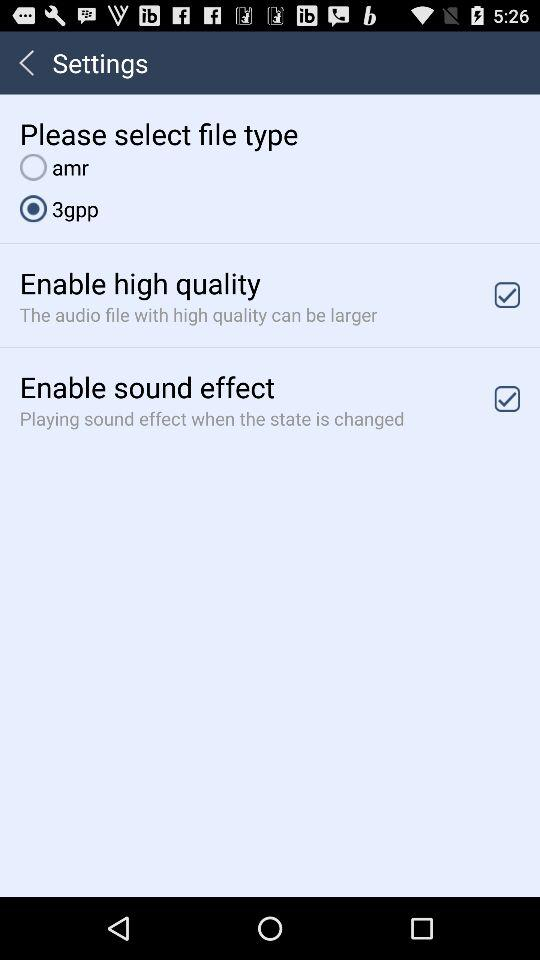What is the status of "Enable high quality"? The status is "on". 